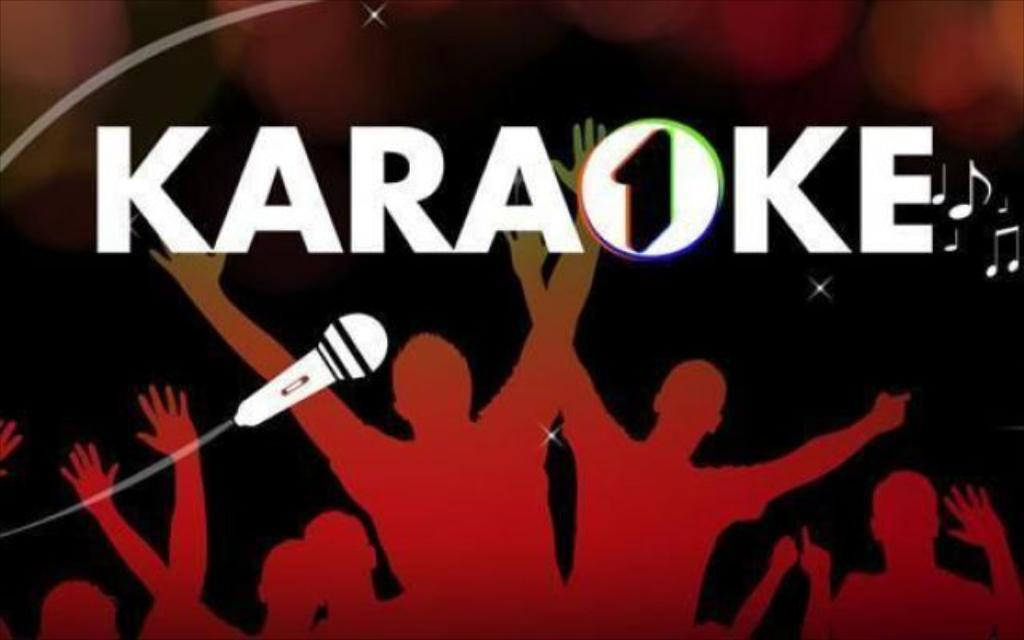<image>
Offer a succinct explanation of the picture presented. Poster that says Karaoke and the shadow of people with a microphone. 